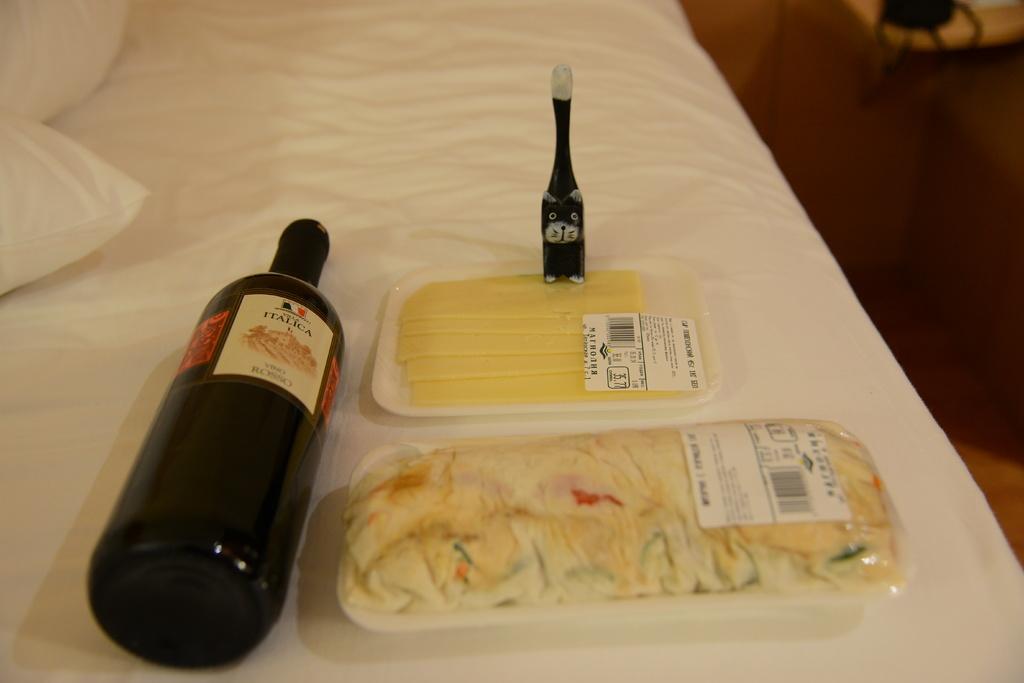What is the name of the wine?
Your answer should be compact. Italica. 